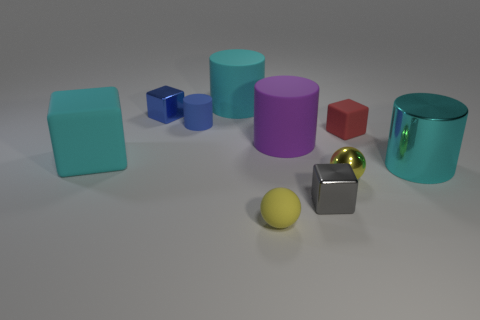Does the matte sphere have the same color as the small metallic ball?
Your answer should be very brief. Yes. Are there any large objects of the same color as the rubber sphere?
Make the answer very short. No. Do the object behind the small blue metallic cube and the big object on the right side of the gray block have the same color?
Offer a terse response. Yes. What is the small red object that is in front of the tiny blue metallic thing made of?
Ensure brevity in your answer.  Rubber. What is the color of the small sphere that is the same material as the small red block?
Your answer should be compact. Yellow. What number of blue metallic objects are the same size as the cyan rubber block?
Your response must be concise. 0. There is a metallic block that is on the left side of the purple object; is it the same size as the large purple matte thing?
Provide a succinct answer. No. The small thing that is behind the big purple rubber thing and right of the small rubber ball has what shape?
Offer a very short reply. Cube. Are there any small yellow matte spheres to the right of the large purple cylinder?
Ensure brevity in your answer.  No. Do the small blue metal thing and the cyan shiny thing have the same shape?
Provide a succinct answer. No. 